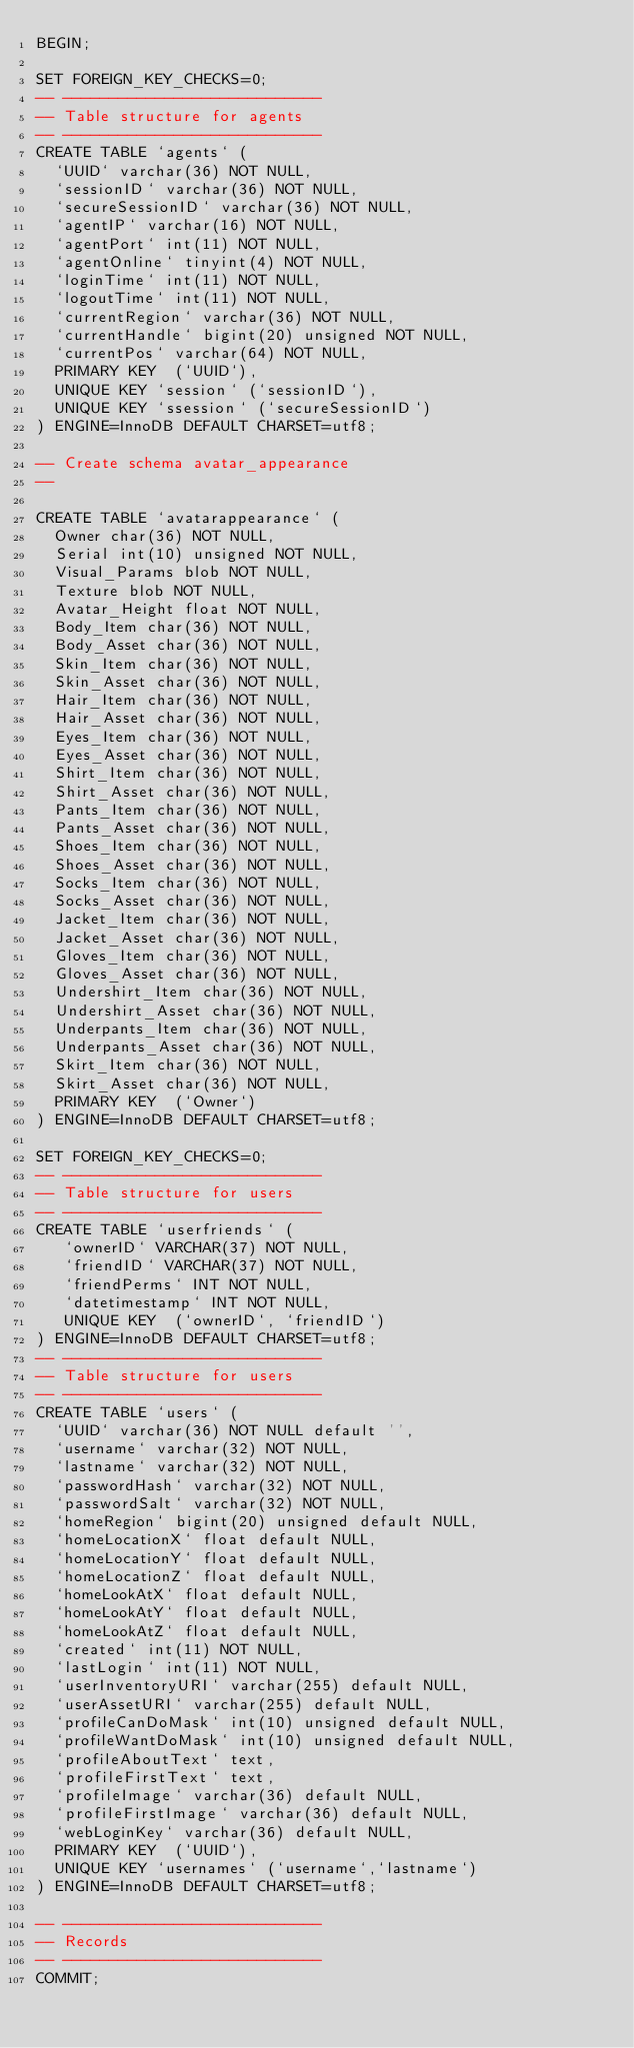<code> <loc_0><loc_0><loc_500><loc_500><_SQL_>BEGIN;

SET FOREIGN_KEY_CHECKS=0;
-- ----------------------------
-- Table structure for agents
-- ----------------------------
CREATE TABLE `agents` (
  `UUID` varchar(36) NOT NULL,
  `sessionID` varchar(36) NOT NULL,
  `secureSessionID` varchar(36) NOT NULL,
  `agentIP` varchar(16) NOT NULL,
  `agentPort` int(11) NOT NULL,
  `agentOnline` tinyint(4) NOT NULL,
  `loginTime` int(11) NOT NULL,
  `logoutTime` int(11) NOT NULL,
  `currentRegion` varchar(36) NOT NULL,
  `currentHandle` bigint(20) unsigned NOT NULL,
  `currentPos` varchar(64) NOT NULL,
  PRIMARY KEY  (`UUID`),
  UNIQUE KEY `session` (`sessionID`),
  UNIQUE KEY `ssession` (`secureSessionID`)
) ENGINE=InnoDB DEFAULT CHARSET=utf8;

-- Create schema avatar_appearance
--

CREATE TABLE `avatarappearance` (
  Owner char(36) NOT NULL,
  Serial int(10) unsigned NOT NULL,
  Visual_Params blob NOT NULL,
  Texture blob NOT NULL,
  Avatar_Height float NOT NULL,
  Body_Item char(36) NOT NULL,
  Body_Asset char(36) NOT NULL,
  Skin_Item char(36) NOT NULL,
  Skin_Asset char(36) NOT NULL,
  Hair_Item char(36) NOT NULL,
  Hair_Asset char(36) NOT NULL,
  Eyes_Item char(36) NOT NULL,
  Eyes_Asset char(36) NOT NULL,
  Shirt_Item char(36) NOT NULL,
  Shirt_Asset char(36) NOT NULL,
  Pants_Item char(36) NOT NULL,
  Pants_Asset char(36) NOT NULL,
  Shoes_Item char(36) NOT NULL,
  Shoes_Asset char(36) NOT NULL,
  Socks_Item char(36) NOT NULL,
  Socks_Asset char(36) NOT NULL,
  Jacket_Item char(36) NOT NULL,
  Jacket_Asset char(36) NOT NULL,
  Gloves_Item char(36) NOT NULL,
  Gloves_Asset char(36) NOT NULL,
  Undershirt_Item char(36) NOT NULL,
  Undershirt_Asset char(36) NOT NULL,
  Underpants_Item char(36) NOT NULL,
  Underpants_Asset char(36) NOT NULL,
  Skirt_Item char(36) NOT NULL,
  Skirt_Asset char(36) NOT NULL,
  PRIMARY KEY  (`Owner`)
) ENGINE=InnoDB DEFAULT CHARSET=utf8;

SET FOREIGN_KEY_CHECKS=0;
-- ----------------------------
-- Table structure for users
-- ----------------------------
CREATE TABLE `userfriends` (
   `ownerID` VARCHAR(37) NOT NULL,
   `friendID` VARCHAR(37) NOT NULL,
   `friendPerms` INT NOT NULL,
   `datetimestamp` INT NOT NULL,
	 UNIQUE KEY  (`ownerID`, `friendID`)
) ENGINE=InnoDB DEFAULT CHARSET=utf8;
-- ----------------------------
-- Table structure for users
-- ----------------------------
CREATE TABLE `users` (
  `UUID` varchar(36) NOT NULL default '',
  `username` varchar(32) NOT NULL,
  `lastname` varchar(32) NOT NULL,
  `passwordHash` varchar(32) NOT NULL,
  `passwordSalt` varchar(32) NOT NULL,
  `homeRegion` bigint(20) unsigned default NULL,
  `homeLocationX` float default NULL,
  `homeLocationY` float default NULL,
  `homeLocationZ` float default NULL,
  `homeLookAtX` float default NULL,
  `homeLookAtY` float default NULL,
  `homeLookAtZ` float default NULL,
  `created` int(11) NOT NULL,
  `lastLogin` int(11) NOT NULL,
  `userInventoryURI` varchar(255) default NULL,
  `userAssetURI` varchar(255) default NULL,
  `profileCanDoMask` int(10) unsigned default NULL,
  `profileWantDoMask` int(10) unsigned default NULL,
  `profileAboutText` text,
  `profileFirstText` text,
  `profileImage` varchar(36) default NULL,
  `profileFirstImage` varchar(36) default NULL,
  `webLoginKey` varchar(36) default NULL,
  PRIMARY KEY  (`UUID`),
  UNIQUE KEY `usernames` (`username`,`lastname`)
) ENGINE=InnoDB DEFAULT CHARSET=utf8;

-- ----------------------------
-- Records 
-- ----------------------------
COMMIT;</code> 